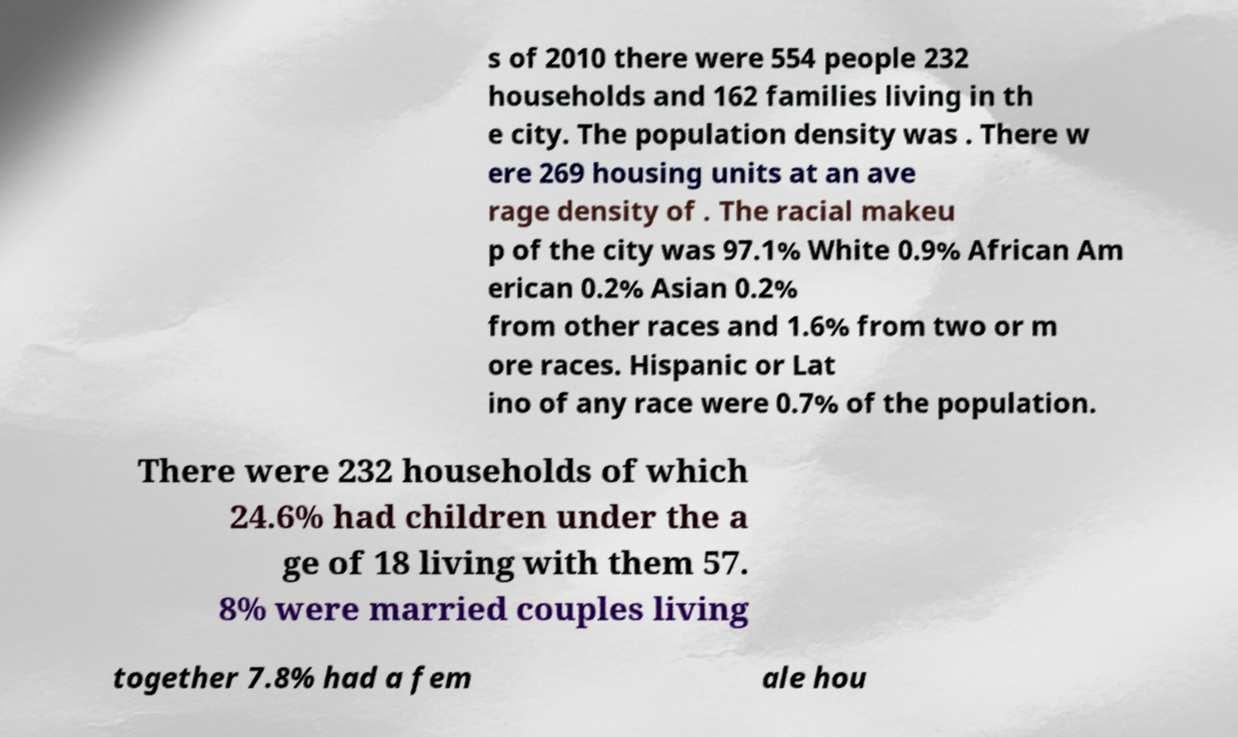Can you read and provide the text displayed in the image?This photo seems to have some interesting text. Can you extract and type it out for me? s of 2010 there were 554 people 232 households and 162 families living in th e city. The population density was . There w ere 269 housing units at an ave rage density of . The racial makeu p of the city was 97.1% White 0.9% African Am erican 0.2% Asian 0.2% from other races and 1.6% from two or m ore races. Hispanic or Lat ino of any race were 0.7% of the population. There were 232 households of which 24.6% had children under the a ge of 18 living with them 57. 8% were married couples living together 7.8% had a fem ale hou 